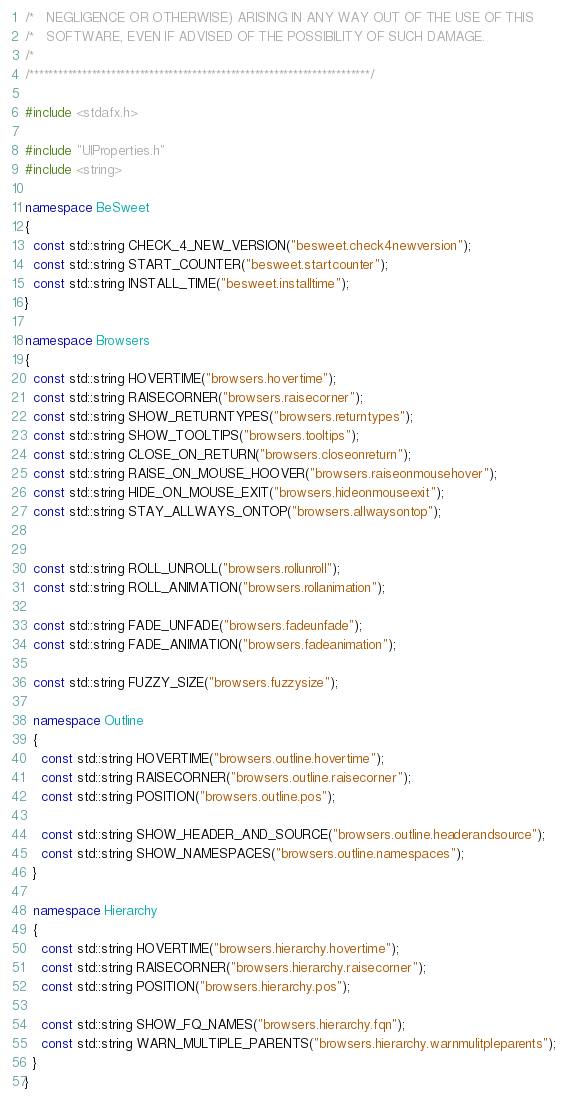Convert code to text. <code><loc_0><loc_0><loc_500><loc_500><_C++_>/*   NEGLIGENCE OR OTHERWISE) ARISING IN ANY WAY OUT OF THE USE OF THIS
/*   SOFTWARE, EVEN IF ADVISED OF THE POSSIBILITY OF SUCH DAMAGE.
/* 
/***********************************************************************/

#include <stdafx.h>

#include "UIProperties.h"
#include <string>

namespace BeSweet
{
  const std::string CHECK_4_NEW_VERSION("besweet.check4newversion");
  const std::string START_COUNTER("besweet.startcounter");
  const std::string INSTALL_TIME("besweet.installtime");
}

namespace Browsers
{
  const std::string HOVERTIME("browsers.hovertime");
  const std::string RAISECORNER("browsers.raisecorner");
  const std::string SHOW_RETURNTYPES("browsers.returntypes");
  const std::string SHOW_TOOLTIPS("browsers.tooltips");
  const std::string CLOSE_ON_RETURN("browsers.closeonreturn");
  const std::string RAISE_ON_MOUSE_HOOVER("browsers.raiseonmousehover");
  const std::string HIDE_ON_MOUSE_EXIT("browsers.hideonmouseexit");
  const std::string STAY_ALLWAYS_ONTOP("browsers.allwaysontop");

  
  const std::string ROLL_UNROLL("browsers.rollunroll");
  const std::string ROLL_ANIMATION("browsers.rollanimation");

  const std::string FADE_UNFADE("browsers.fadeunfade");
  const std::string FADE_ANIMATION("browsers.fadeanimation");

  const std::string FUZZY_SIZE("browsers.fuzzysize");

  namespace Outline
  {
    const std::string HOVERTIME("browsers.outline.hovertime");
    const std::string RAISECORNER("browsers.outline.raisecorner");
    const std::string POSITION("browsers.outline.pos");

    const std::string SHOW_HEADER_AND_SOURCE("browsers.outline.headerandsource");
    const std::string SHOW_NAMESPACES("browsers.outline.namespaces");
  }

  namespace Hierarchy
  {
    const std::string HOVERTIME("browsers.hierarchy.hovertime");
    const std::string RAISECORNER("browsers.hierarchy.raisecorner");
    const std::string POSITION("browsers.hierarchy.pos");

    const std::string SHOW_FQ_NAMES("browsers.hierarchy.fqn");  
    const std::string WARN_MULTIPLE_PARENTS("browsers.hierarchy.warnmulitpleparents");
  }
}</code> 